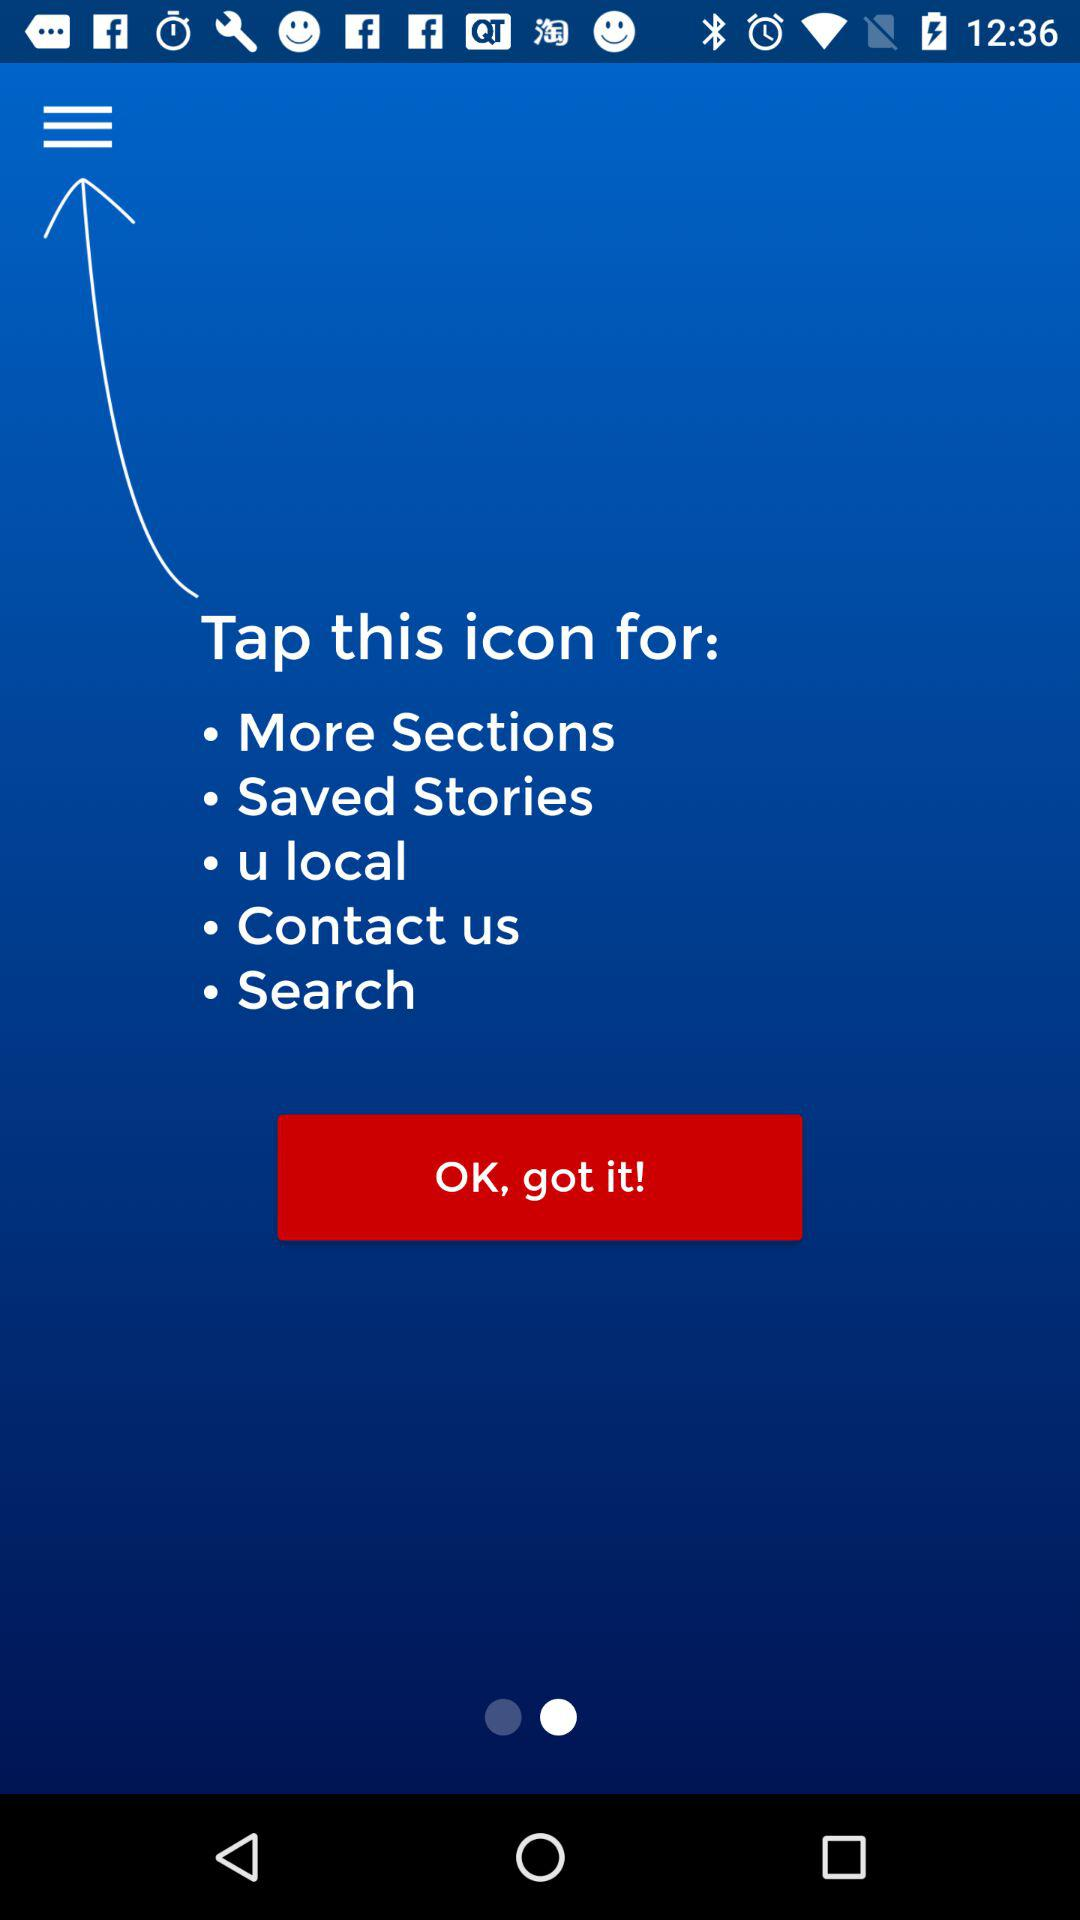How many sections are there in the menu?
Answer the question using a single word or phrase. 5 